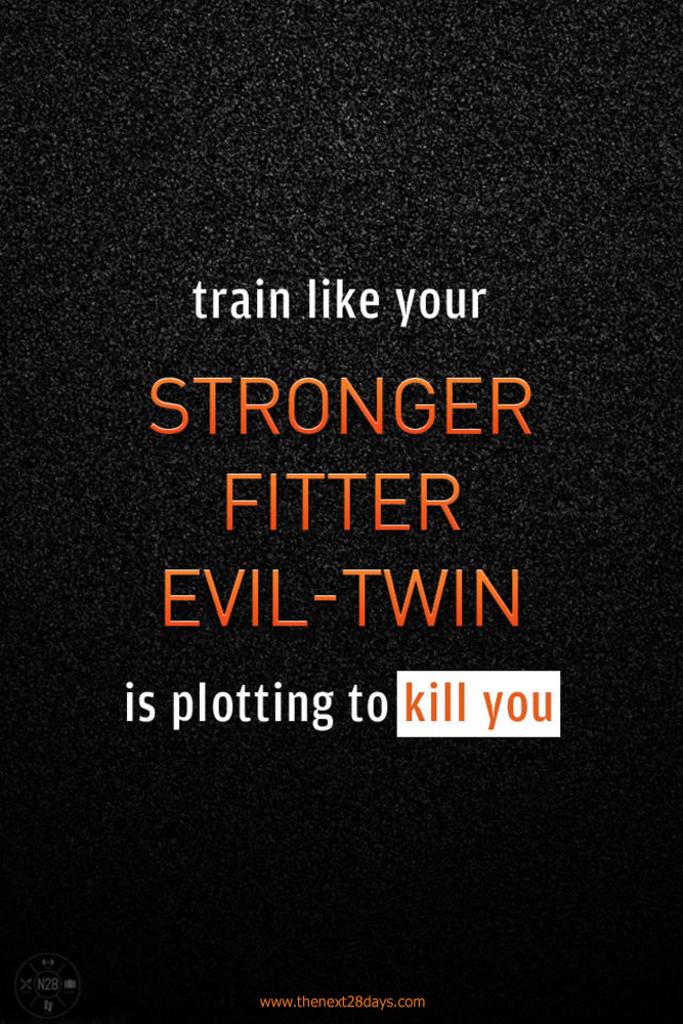What do you need to do?
Give a very brief answer. Train like your stronger fitter evil-twin is plotting to kill you. 